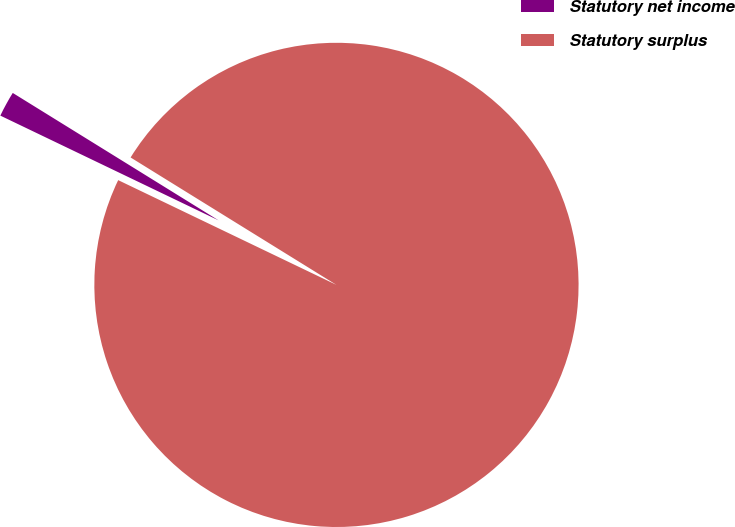<chart> <loc_0><loc_0><loc_500><loc_500><pie_chart><fcel>Statutory net income<fcel>Statutory surplus<nl><fcel>1.7%<fcel>98.3%<nl></chart> 